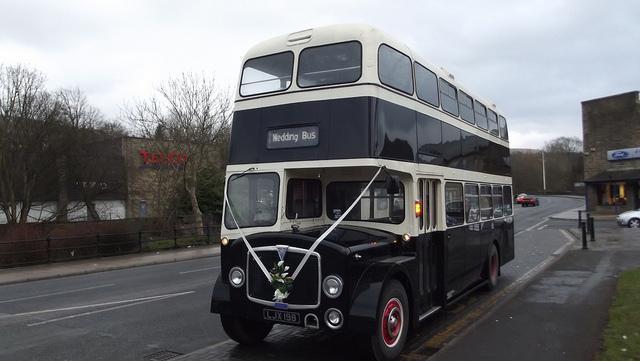How many lights are on the front of the bus?
Give a very brief answer. 3. How many stories are on this bus?
Give a very brief answer. 2. 